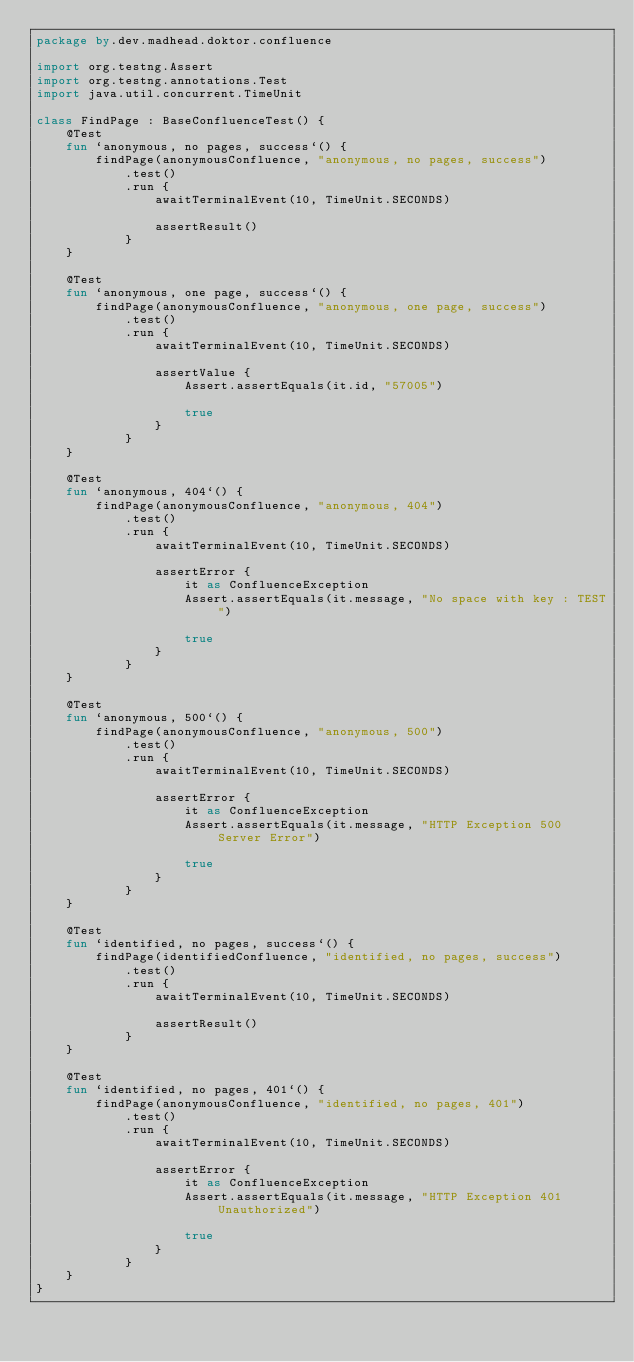Convert code to text. <code><loc_0><loc_0><loc_500><loc_500><_Kotlin_>package by.dev.madhead.doktor.confluence

import org.testng.Assert
import org.testng.annotations.Test
import java.util.concurrent.TimeUnit

class FindPage : BaseConfluenceTest() {
	@Test
	fun `anonymous, no pages, success`() {
		findPage(anonymousConfluence, "anonymous, no pages, success")
			.test()
			.run {
				awaitTerminalEvent(10, TimeUnit.SECONDS)

				assertResult()
			}
	}

	@Test
	fun `anonymous, one page, success`() {
		findPage(anonymousConfluence, "anonymous, one page, success")
			.test()
			.run {
				awaitTerminalEvent(10, TimeUnit.SECONDS)

				assertValue {
					Assert.assertEquals(it.id, "57005")

					true
				}
			}
	}

	@Test
	fun `anonymous, 404`() {
		findPage(anonymousConfluence, "anonymous, 404")
			.test()
			.run {
				awaitTerminalEvent(10, TimeUnit.SECONDS)

				assertError {
					it as ConfluenceException
					Assert.assertEquals(it.message, "No space with key : TEST")

					true
				}
			}
	}

	@Test
	fun `anonymous, 500`() {
		findPage(anonymousConfluence, "anonymous, 500")
			.test()
			.run {
				awaitTerminalEvent(10, TimeUnit.SECONDS)

				assertError {
					it as ConfluenceException
					Assert.assertEquals(it.message, "HTTP Exception 500 Server Error")

					true
				}
			}
	}

	@Test
	fun `identified, no pages, success`() {
		findPage(identifiedConfluence, "identified, no pages, success")
			.test()
			.run {
				awaitTerminalEvent(10, TimeUnit.SECONDS)

				assertResult()
			}
	}

	@Test
	fun `identified, no pages, 401`() {
		findPage(anonymousConfluence, "identified, no pages, 401")
			.test()
			.run {
				awaitTerminalEvent(10, TimeUnit.SECONDS)

				assertError {
					it as ConfluenceException
					Assert.assertEquals(it.message, "HTTP Exception 401 Unauthorized")

					true
				}
			}
	}
}
</code> 